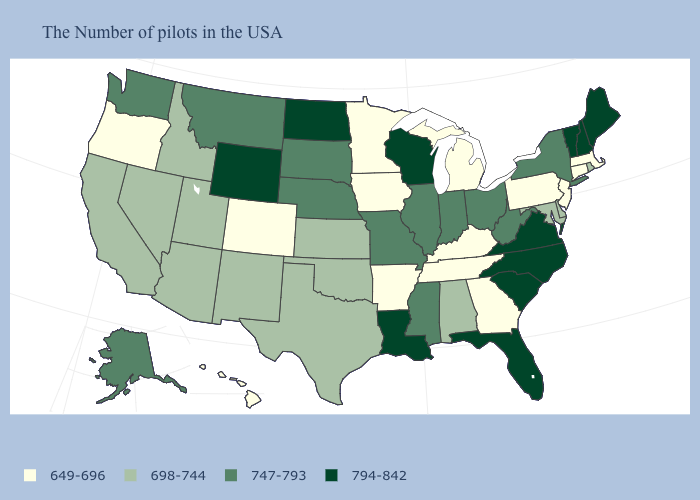What is the value of Massachusetts?
Keep it brief. 649-696. Does Georgia have the lowest value in the USA?
Concise answer only. Yes. Among the states that border Maine , which have the lowest value?
Short answer required. New Hampshire. What is the value of Massachusetts?
Give a very brief answer. 649-696. Does Georgia have a lower value than Mississippi?
Write a very short answer. Yes. Name the states that have a value in the range 649-696?
Keep it brief. Massachusetts, Connecticut, New Jersey, Pennsylvania, Georgia, Michigan, Kentucky, Tennessee, Arkansas, Minnesota, Iowa, Colorado, Oregon, Hawaii. Which states have the lowest value in the USA?
Be succinct. Massachusetts, Connecticut, New Jersey, Pennsylvania, Georgia, Michigan, Kentucky, Tennessee, Arkansas, Minnesota, Iowa, Colorado, Oregon, Hawaii. What is the value of Wyoming?
Answer briefly. 794-842. What is the value of North Carolina?
Concise answer only. 794-842. Name the states that have a value in the range 698-744?
Short answer required. Rhode Island, Delaware, Maryland, Alabama, Kansas, Oklahoma, Texas, New Mexico, Utah, Arizona, Idaho, Nevada, California. How many symbols are there in the legend?
Write a very short answer. 4. Among the states that border Oregon , does Idaho have the highest value?
Short answer required. No. Does Washington have the same value as California?
Quick response, please. No. Among the states that border Indiana , which have the highest value?
Write a very short answer. Ohio, Illinois. Among the states that border Georgia , which have the highest value?
Concise answer only. North Carolina, South Carolina, Florida. 